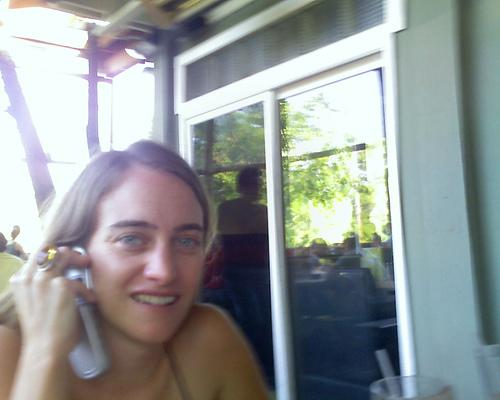Where is she most likely having a conversation on her cellphone? Please explain your reasoning. restaurant. The windows reflect many people in this setting most of which are sitting, she also has a drink with a straw in it sitting directly in front of her. 